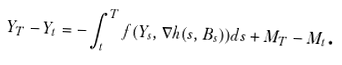<formula> <loc_0><loc_0><loc_500><loc_500>Y _ { T } - Y _ { t } = - \int _ { t } ^ { T } f ( Y _ { s } , \nabla h ( s , B _ { s } ) ) d s + M _ { T } - M _ { t } \text {.}</formula> 